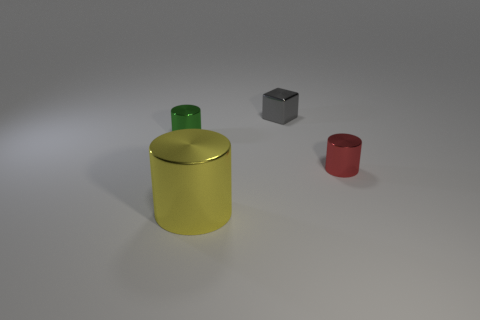Is the material of the gray object the same as the small green object?
Provide a short and direct response. Yes. What number of red metal cylinders are in front of the object left of the yellow metallic thing?
Offer a very short reply. 1. Do the gray object and the red object have the same size?
Ensure brevity in your answer.  Yes. How many small green objects have the same material as the small block?
Your answer should be very brief. 1. There is a yellow thing that is the same shape as the tiny green metal thing; what is its size?
Your response must be concise. Large. Do the thing left of the big yellow shiny thing and the big yellow object have the same shape?
Offer a terse response. Yes. There is a thing behind the tiny metal object that is left of the tiny gray metal block; what shape is it?
Provide a short and direct response. Cube. Is there any other thing that has the same shape as the gray object?
Offer a terse response. No. There is another tiny shiny object that is the same shape as the tiny green object; what is its color?
Offer a terse response. Red. Do the large thing and the tiny object that is in front of the green shiny thing have the same color?
Provide a short and direct response. No. 